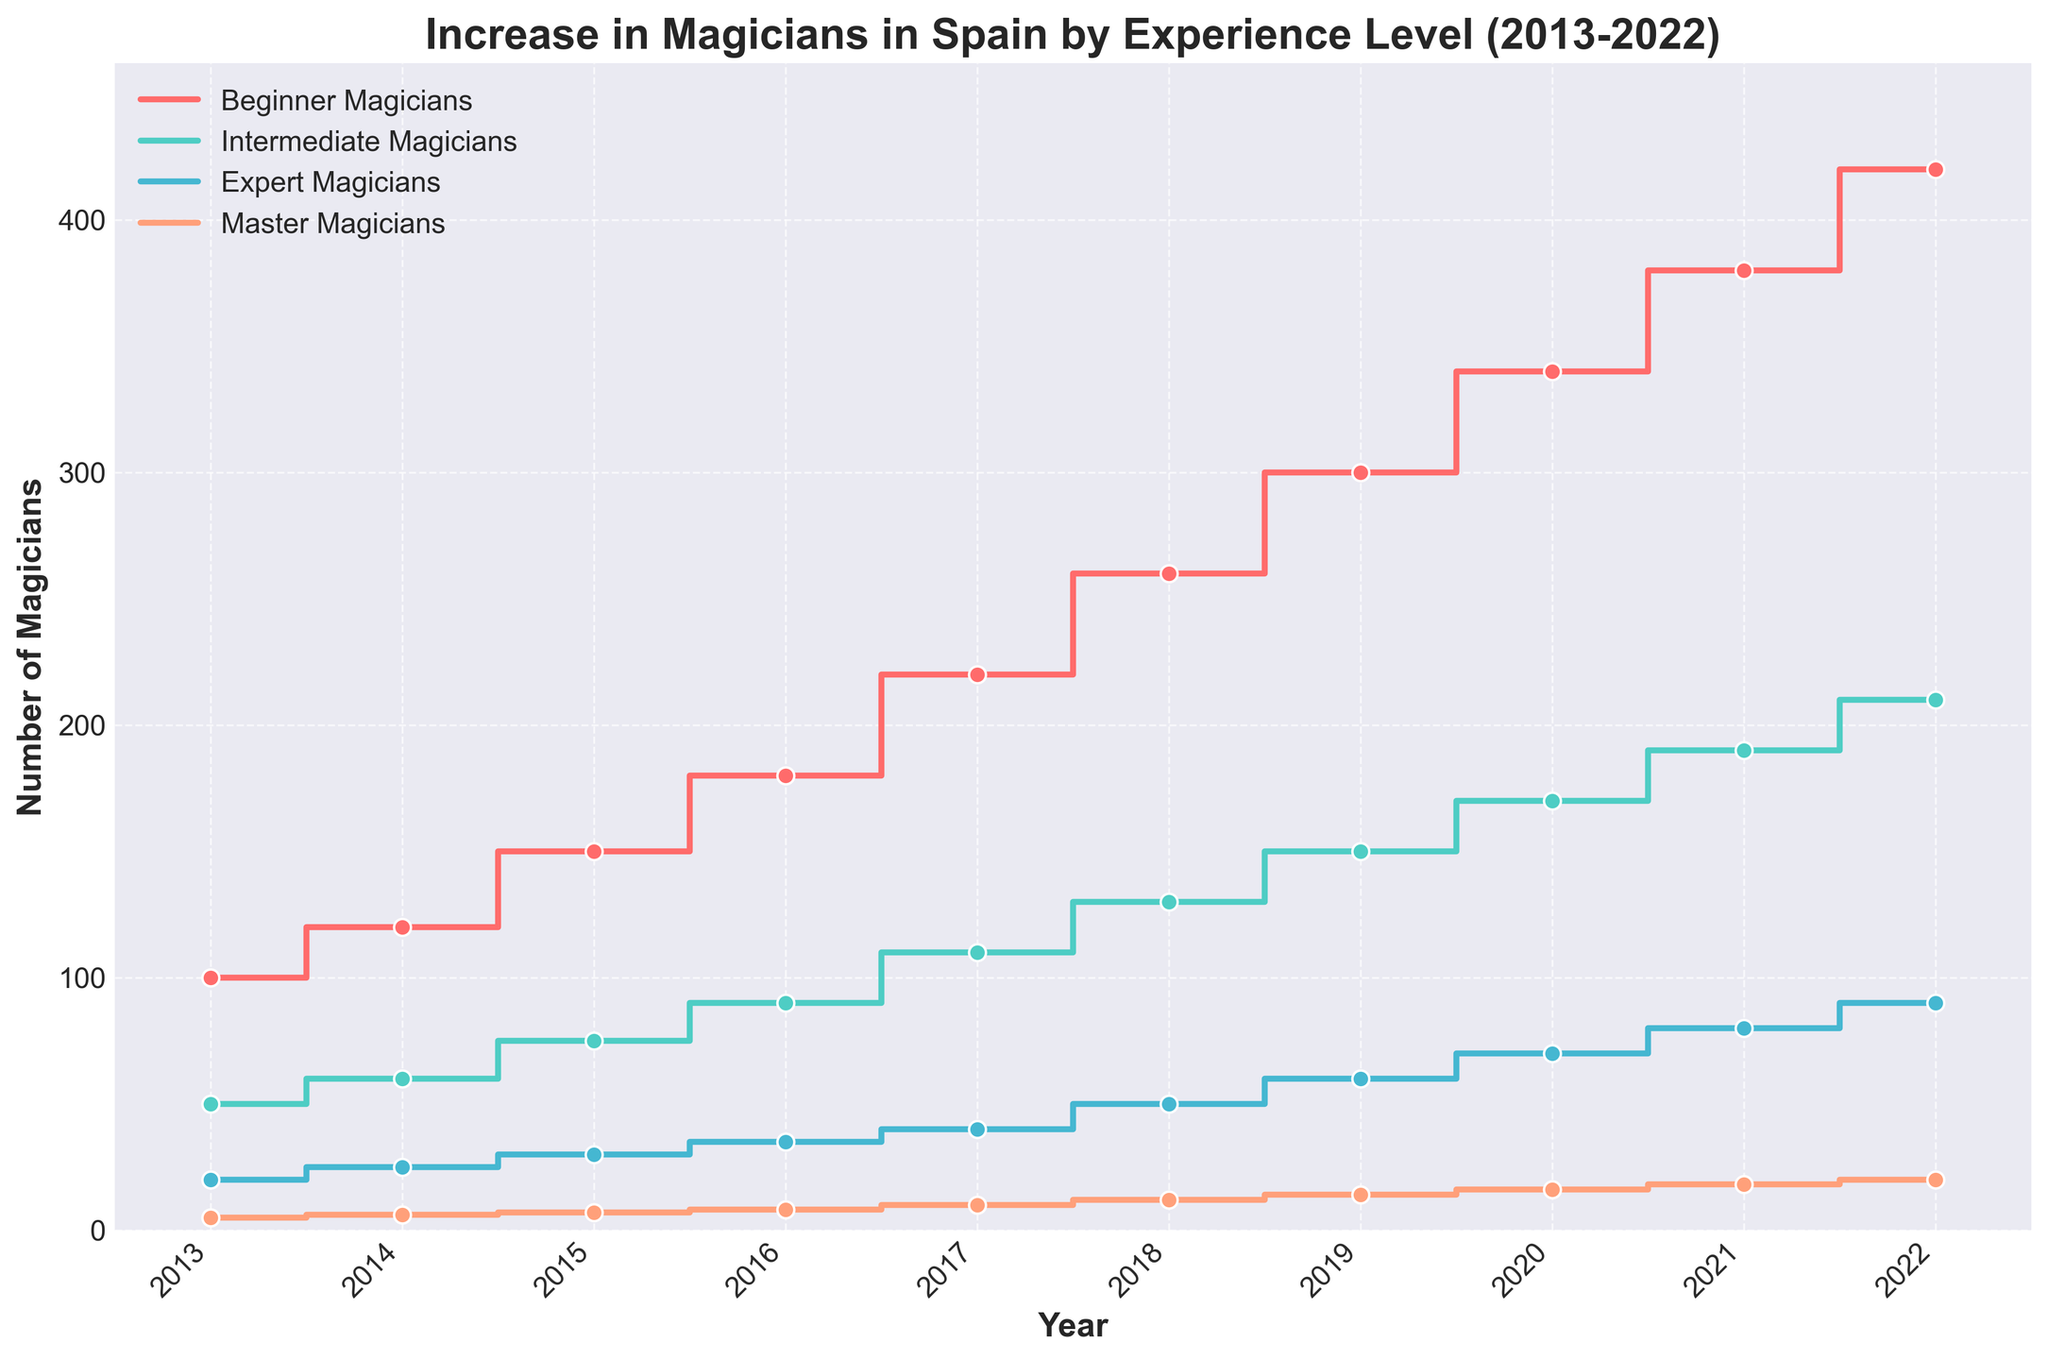What's the title of the plot? The title is the text displayed at the top of the plot; it usually summarizes the content or purpose of the plot.
Answer: Increase in Magicians in Spain by Experience Level (2013-2022) What are the x-axis and y-axis labels? The x-axis label is the text along the horizontal axis, and the y-axis label is the text along the vertical axis. The x-axis typically indicates time or categories, while the y-axis represents the measured values.
Answer: Year and Number of Magicians Which experience level had the most significant increase from 2013 to 2022? Find the difference between the values in 2022 and 2013 for each experience level, then compare these differences. Beginner Magicians: 420-100=320, Intermediate Magicians: 210-50=160, Expert Magicians: 90-20=70, Master Magicians: 20-5=15.
Answer: Beginner Magicians How many beginner magicians were there in 2017? Locate the year 2017 on the x-axis and find the corresponding point for the beginner magicians series, which is the red line with markers.
Answer: 220 What is the combined number of expert and master magicians in 2020? Add the number of expert magicians (70) to the number of master magicians (16) for the year 2020. 70 + 16 = 86
Answer: 86 In which year did the number of intermediate magicians reach 150? Identify the year on the x-axis where the intermediate magicians' series intersects the value 150 on the y-axis.
Answer: 2019 Did the number of master magicians ever surpass 20 in any year? Check the master magicians' series (orange line with markers) and see if it reaches or goes beyond 20 in any year. The plot shows the highest value as 20 in 2022.
Answer: No What’s the difference in the number of beginner magicians between 2014 and 2018? Subtract the number of beginner magicians in 2014 (120) from the number in 2018 (260). 260 - 120 = 140
Answer: 140 Which experience level had the smoothest, most gradual increase over the years? Observe the lines and find the one that has the least steep changes between years. The intermediate magicians (green line) shows a consistent, steady increase.
Answer: Intermediate Magicians 